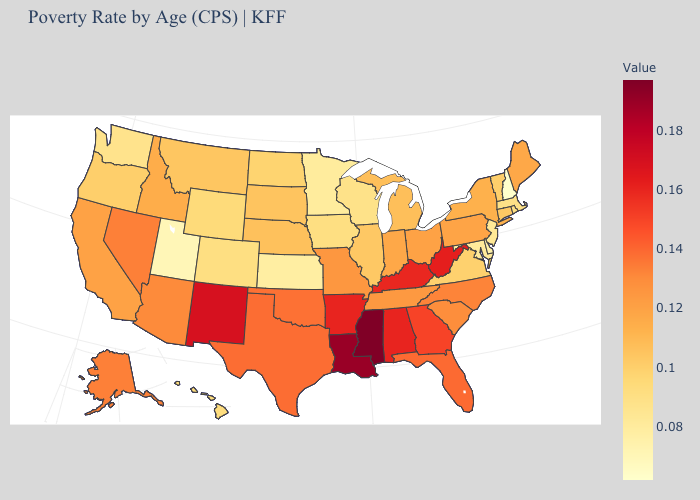Among the states that border Massachusetts , does New Hampshire have the lowest value?
Be succinct. Yes. Does Missouri have the highest value in the MidWest?
Be succinct. Yes. Among the states that border Florida , does Alabama have the highest value?
Give a very brief answer. Yes. Does South Carolina have a lower value than Montana?
Write a very short answer. No. Among the states that border Indiana , does Michigan have the highest value?
Keep it brief. No. Which states have the lowest value in the South?
Write a very short answer. Delaware. 